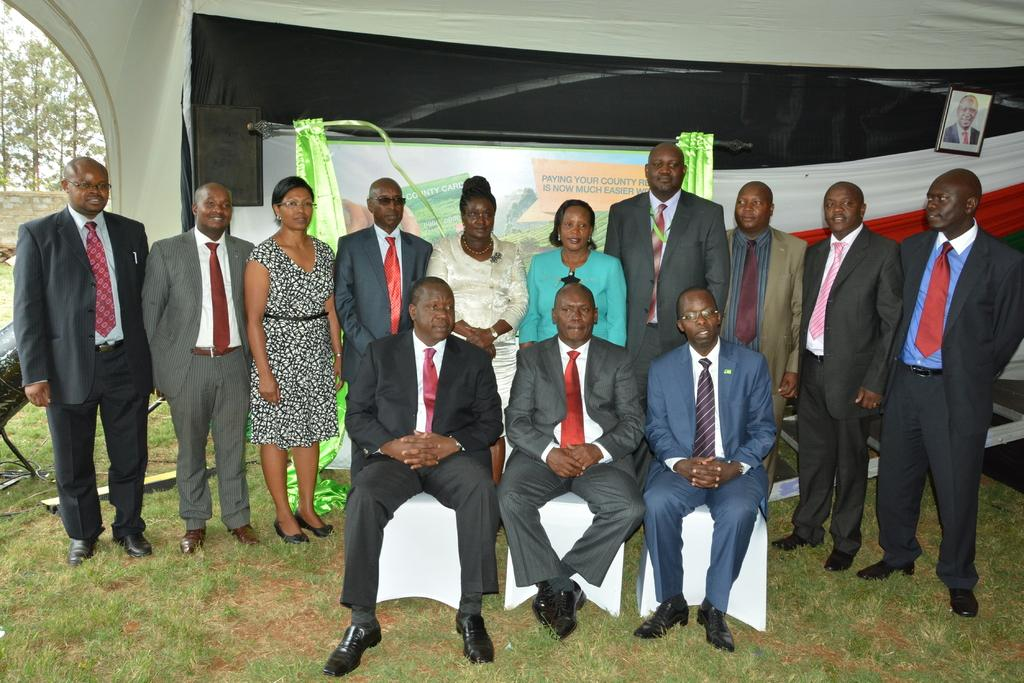What are the people in the image doing? Some people are standing, and others are sitting on chairs in the image. What can be seen hanging in the image? There is a banner in the image. What type of object is present in the image that might hold a picture? There is a photo frame in the image. What type of war is depicted in the image? There is no depiction of war in the image; it features people standing and sitting, a banner, and a photo frame. How many snakes can be seen slithering on the floor in the image? There are no snakes present in the image. 